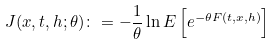<formula> <loc_0><loc_0><loc_500><loc_500>J ( x , t , h ; \theta ) \colon = - \frac { 1 } { \theta } \ln E \left [ e ^ { - \theta F ( t , x , h ) } \right ]</formula> 